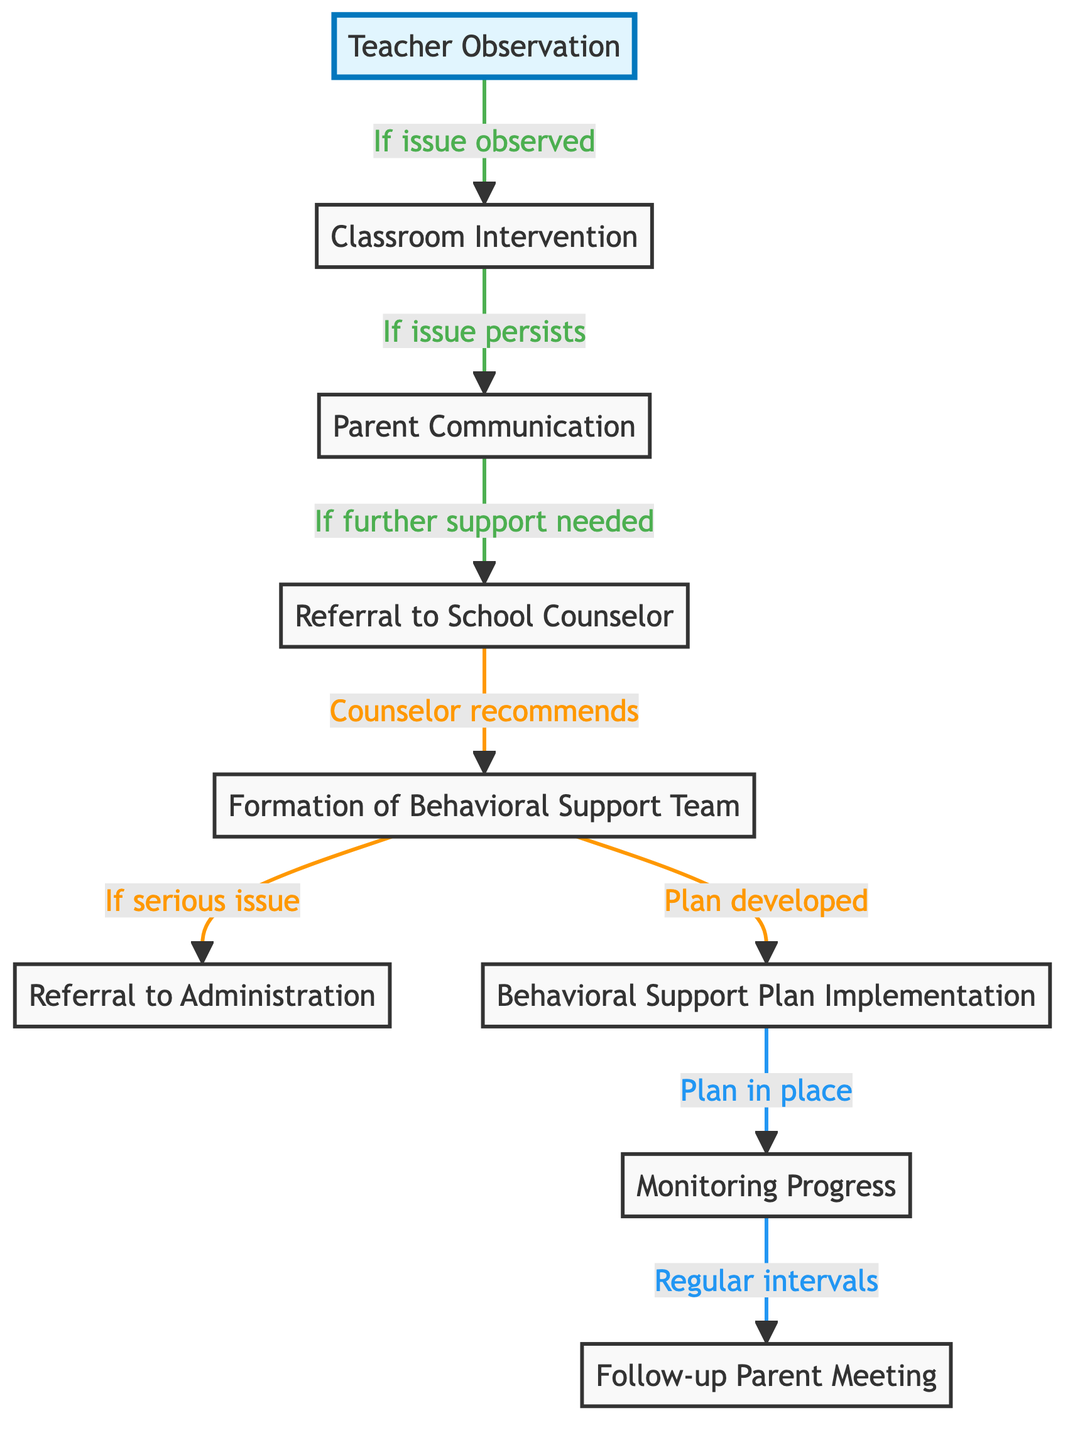what is the starting point of the referral process? The diagram indicates that the starting point is "Teacher Observation," as it is the first node in the sequence and no other node precedes it.
Answer: Teacher Observation how many total nodes are in the diagram? By counting, there are 9 nodes listed in the data section, which represent distinct steps or stages in the referral process.
Answer: 9 what happens if a classroom intervention is not successful? The diagram shows that if the "Classroom Intervention" is not successful, it leads to "Parent Communication," indicating that the next step is to communicate with the parents.
Answer: Parent Communication what is formed after the referral to the school counselor? According to the flow, after the "Referral to School Counselor," the next step is the "Formation of Behavioral Support Team," which is explicitly stated as the action taken by the counselor.
Answer: Formation of Behavioral Support Team how is progress monitored after the implementation of the behavioral support plan? The diagram indicates that once the "Behavioral Support Plan" is implemented, it leads to the node "Monitoring Progress," which shows that this is how progress is tracked after implementing the plan.
Answer: Monitoring Progress what is the final step in the referral process? The final step in the referral process is identified in the diagram as "Follow-up Parent Meeting," marking the conclusion of the sequence of actions taken.
Answer: Follow-up Parent Meeting what is the relationship between the referral to the counselor and the formation of the behavioral support team? The diagram illustrates that the relationship is that the referral to the counselor leads to the formation of the behavioral support team, with the counselor recommending this action to further the support of the student.
Answer: Counselor recommends what needs to happen before a behavioral support plan can be developed? The diagram specifies that a "Formation of Behavioral Support Team" must occur before a "Behavioral Support Plan" can be developed, ensuring that the team is in place to create the necessary support.
Answer: Plan developed if a serious issue is identified, what is the subsequent action taken? Based on the flow of the diagram, if a serious issue is identified during the behavioral support process, it leads to a "Referral to Administration," showing that this is the next course of action.
Answer: Referral to Administration 